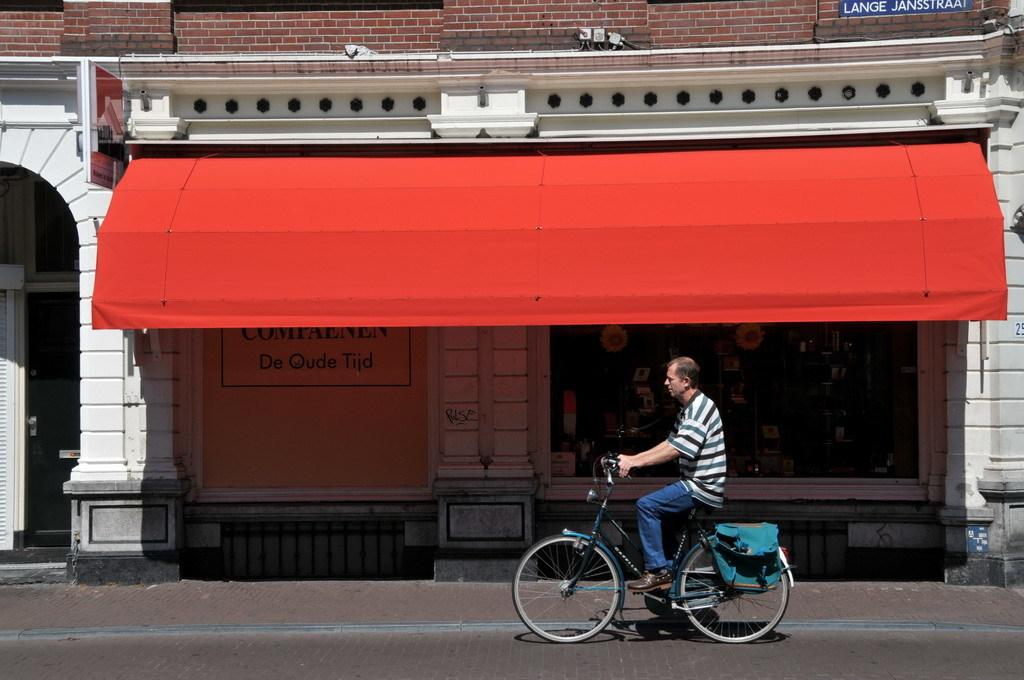What is the main subject of the image? The main subject of the image is a guy riding a bicycle. What can be seen in the background of the image? There is a shop in the background of the image. What is the color of the tent on top of the shop? The tent on top of the shop has a red color. Is the guy riding the bicycle experiencing any pain in his leg in the image? There is no indication in the image that the guy riding the bicycle is experiencing pain in his leg. Can you see any goats in the image? There are no goats present in the image. 